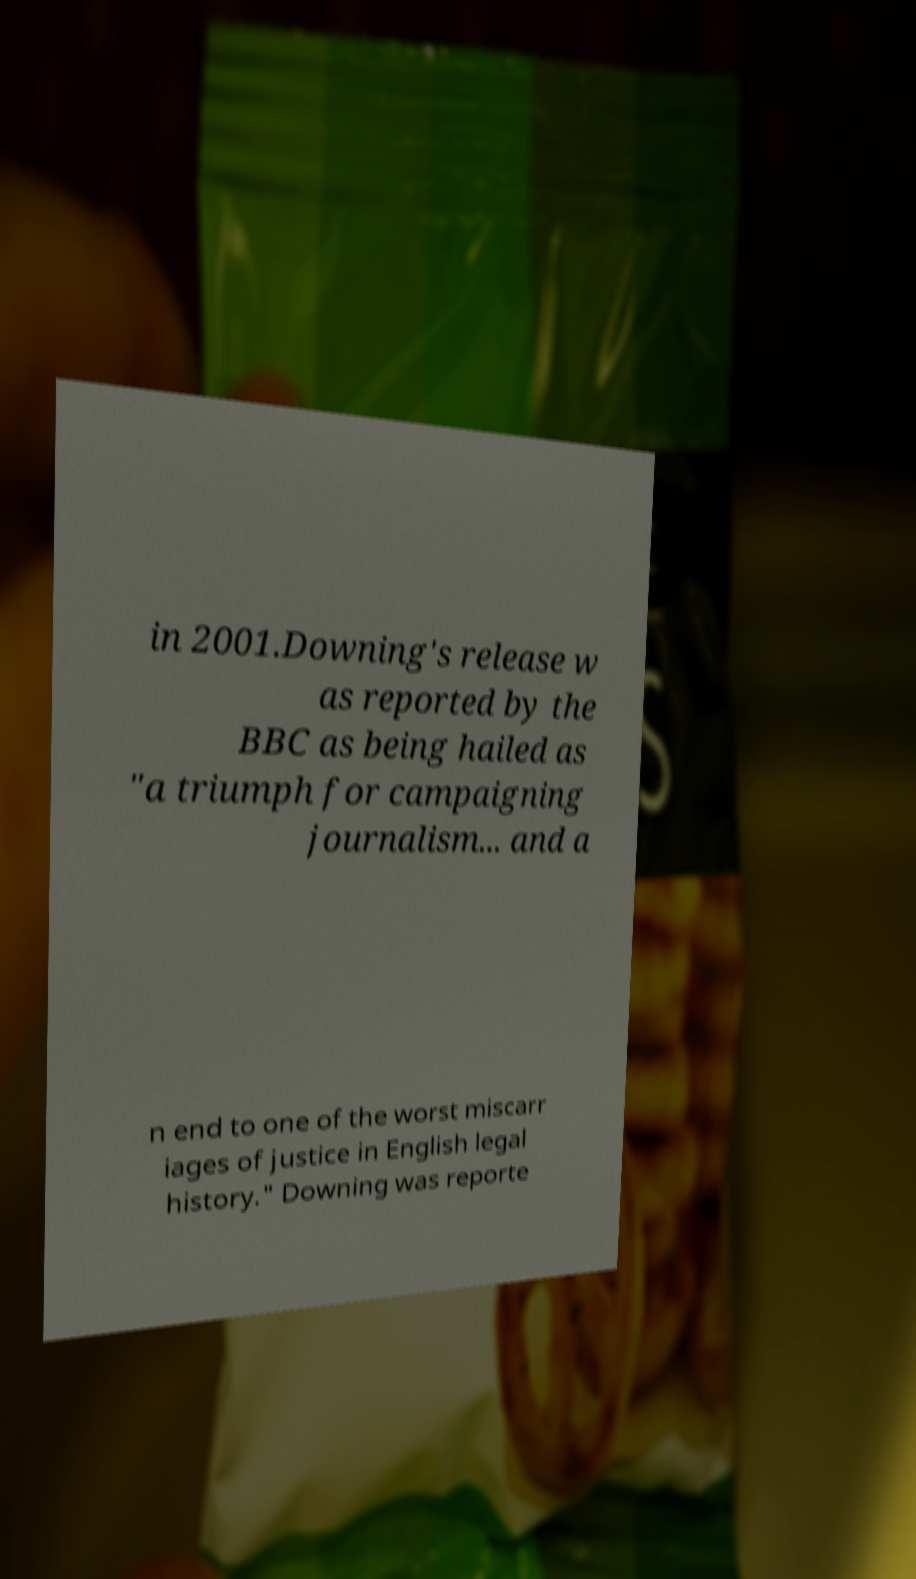There's text embedded in this image that I need extracted. Can you transcribe it verbatim? in 2001.Downing's release w as reported by the BBC as being hailed as "a triumph for campaigning journalism... and a n end to one of the worst miscarr iages of justice in English legal history." Downing was reporte 